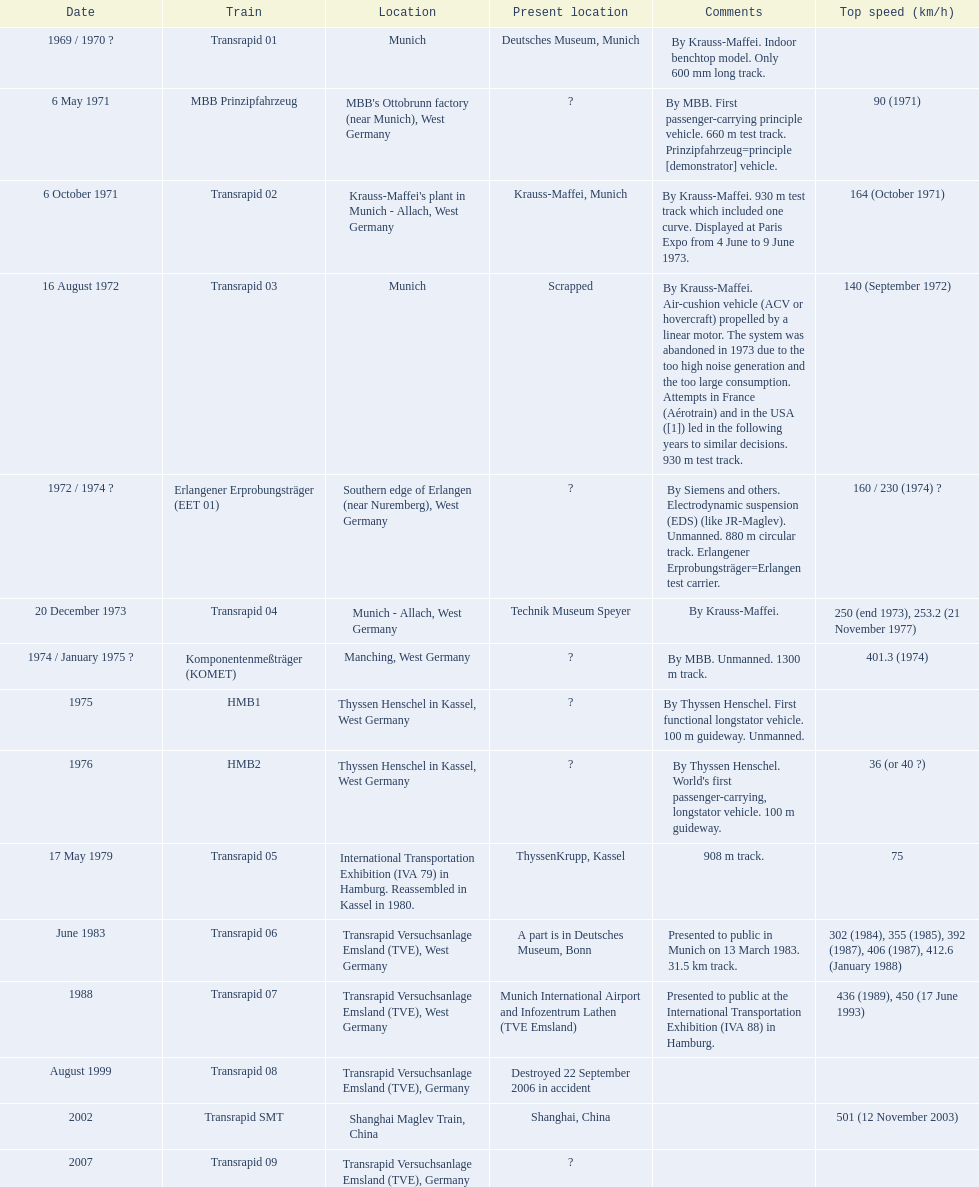What is the top speed reached by any trains shown here? 501 (12 November 2003). What train has reached a top speed of 501? Transrapid SMT. 